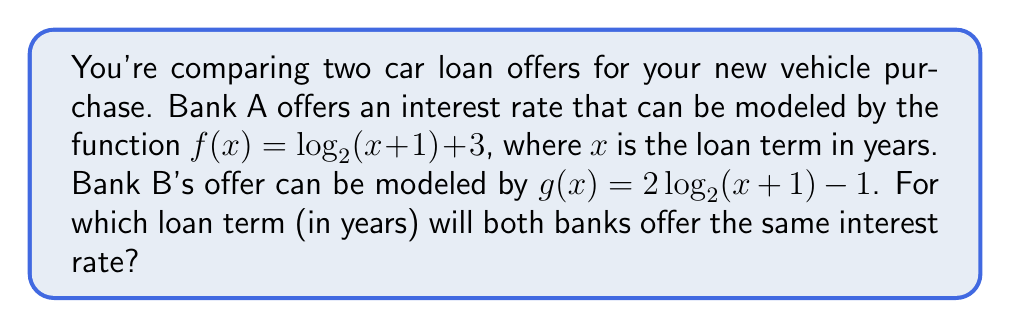Give your solution to this math problem. To find when both banks offer the same interest rate, we need to solve the equation:

$f(x) = g(x)$

1) Substitute the given functions:
   $\log_2(x + 1) + 3 = 2\log_2(x + 1) - 1$

2) Subtract $\log_2(x + 1)$ from both sides:
   $3 = \log_2(x + 1) - 1$

3) Add 1 to both sides:
   $4 = \log_2(x + 1)$

4) Apply $2^x$ to both sides:
   $2^4 = 2^{\log_2(x + 1)}$

5) Simplify the left side:
   $16 = x + 1$

6) Subtract 1 from both sides:
   $15 = x$

Therefore, both banks will offer the same interest rate when the loan term is 15 years.
Answer: 15 years 